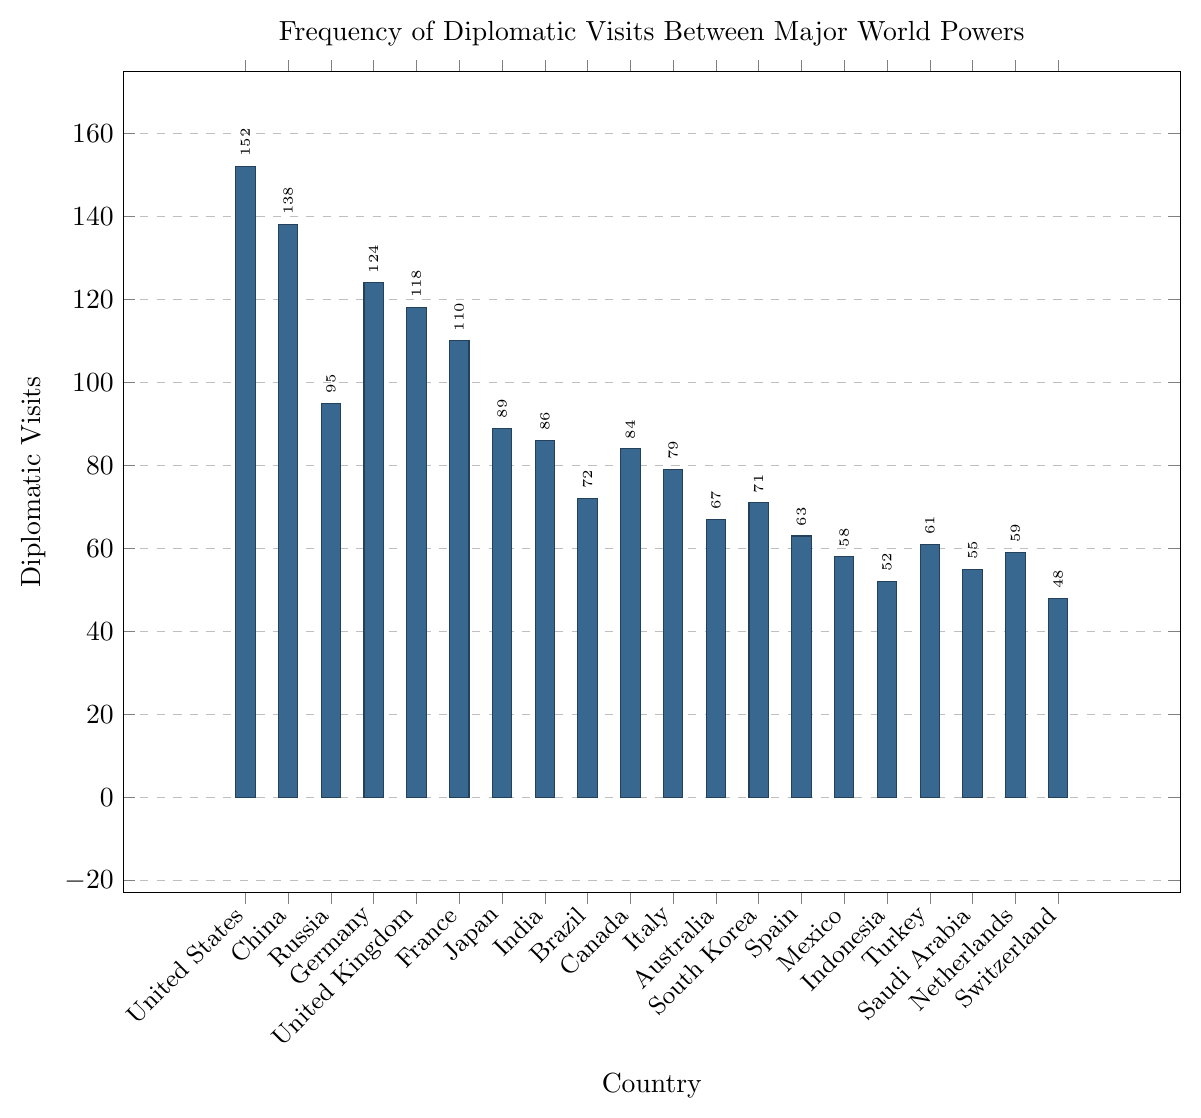What is the total number of diplomatic visits by the three countries with the highest frequencies? First, identify the three countries with the highest frequencies: United States (152), China (138), and Germany (124). Then, sum their diplomatic visits: 152 + 138 + 124 = 414.
Answer: 414 Which country has the least number of diplomatic visits? Identify the country with the smallest bar height on the plot. The shortest bar represents Switzerland with 48 visits.
Answer: Switzerland Is the number of diplomatic visits by the United States greater than the combined visits by Mexico and Indonesia? Compare the number of visits by the United States (152) with the sum of visits by Mexico (58) and Indonesia (52). Mexico and Indonesia combined have 58 + 52 = 110 visits, which is less than 152.
Answer: Yes What is the difference in the number of diplomatic visits between Germany and France? Find the number of visits for both Germany (124) and France (110). Then, subtract France's visits from Germany's visits: 124 - 110 = 14.
Answer: 14 Which countries have more than 100 diplomatic visits? Identify the countries with bars higher than the 100 mark:
United States (152), China (138), Germany (124), United Kingdom (118), France (110).
Answer: United States, China, Germany, United Kingdom, France What is the average number of diplomatic visits for the countries shown in the figure? Sum all the visits and divide by the number of countries: (152 + 138 + 95 + 124 + 118 + 110 + 89 + 86 + 72 + 84 + 79 + 67 + 71 + 63 + 58 + 52 + 61 + 55 + 59 + 48) / 20 = 1665 / 20 = 83.25.
Answer: 83.25 Which country has more diplomatic visits: Japan or Brazil? Compare the number of visits for both Japan (89) and Brazil (72). Japan has more diplomatic visits.
Answer: Japan What is the median number of diplomatic visits? First, order the visits from least to greatest and find the middle value(s):
[48, 52, 55, 58, 59, 61, 63, 67, 71, 72, 79, 84, 86, 89, 95, 110, 118, 124, 138, 152]. The middle values (10th and 11th) are 72 and 79; average them: (72 + 79) / 2 = 75.5.
Answer: 75.5 How do the diplomatic visits to Russia compare to those to China? Compare the number of visits: Russia (95) and China (138). China's visits are higher than Russia's.
Answer: China What is the total number of diplomatic visits by European countries shown in the figure? (Consider Germany, United Kingdom, France, Italy, Spain, Netherlands, Switzerland) Sum the visits for Germany (124), United Kingdom (118), France (110), Italy (79), Spain (63), Netherlands (59), Switzerland (48): 124 + 118 + 110 + 79 + 63 + 59 + 48 = 601.
Answer: 601 